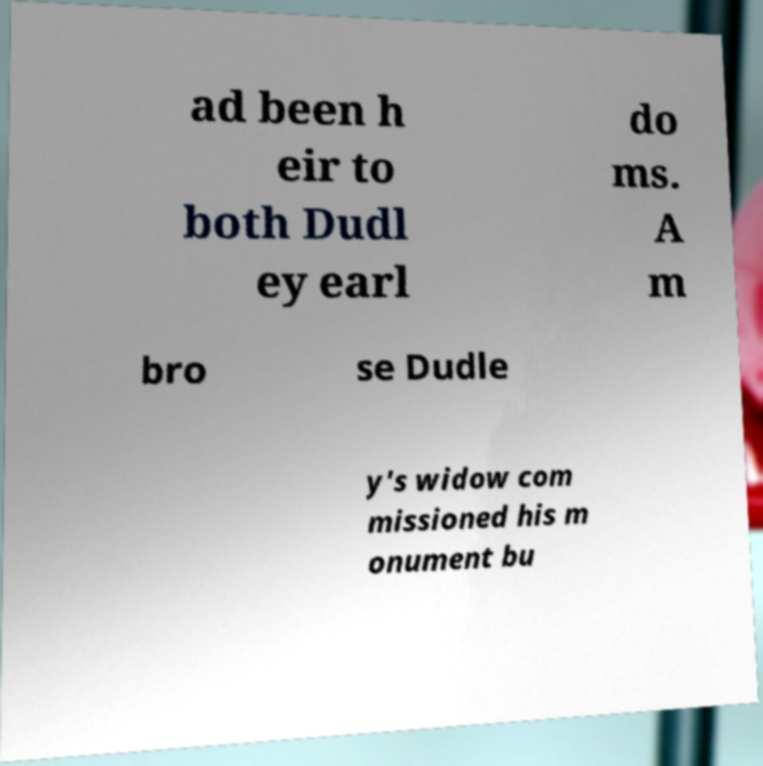I need the written content from this picture converted into text. Can you do that? ad been h eir to both Dudl ey earl do ms. A m bro se Dudle y's widow com missioned his m onument bu 